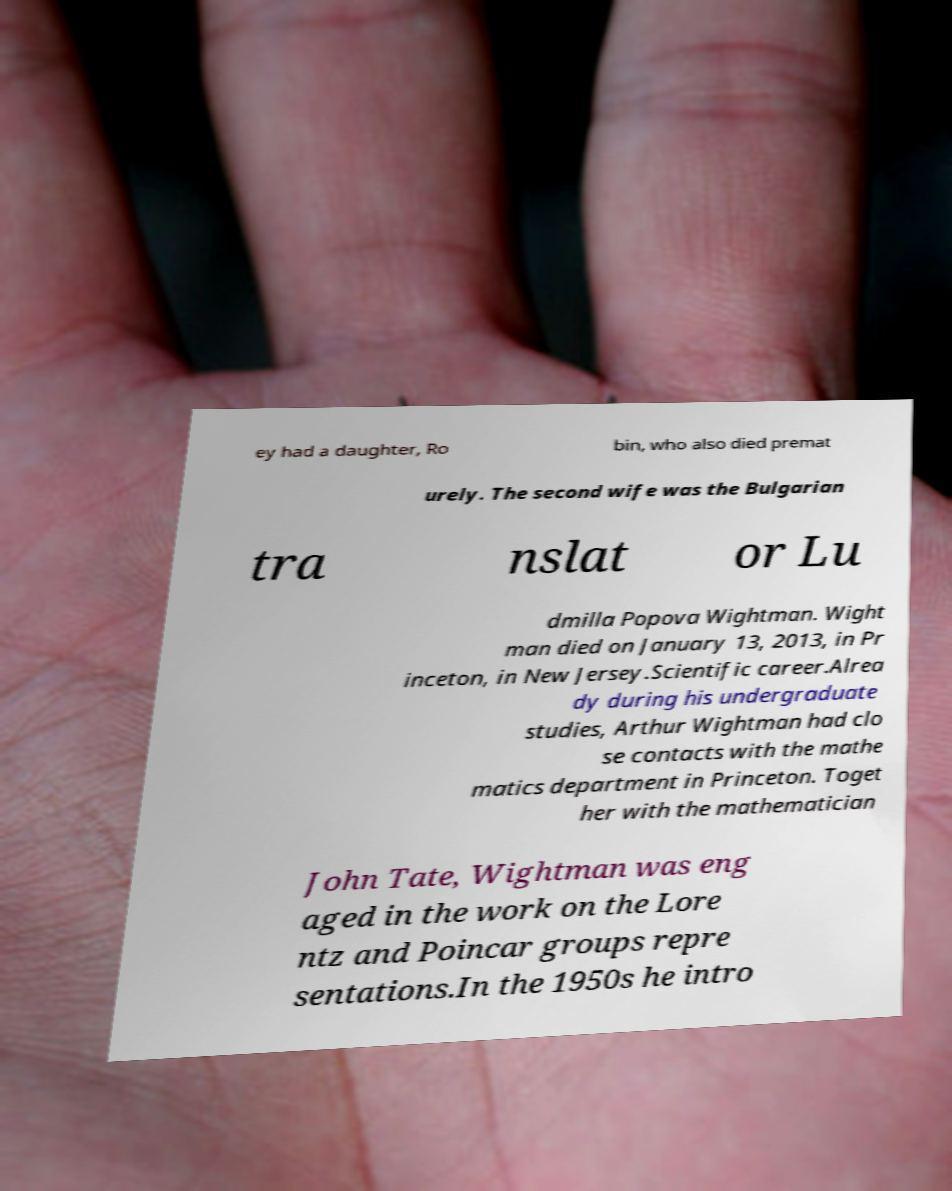Please identify and transcribe the text found in this image. ey had a daughter, Ro bin, who also died premat urely. The second wife was the Bulgarian tra nslat or Lu dmilla Popova Wightman. Wight man died on January 13, 2013, in Pr inceton, in New Jersey.Scientific career.Alrea dy during his undergraduate studies, Arthur Wightman had clo se contacts with the mathe matics department in Princeton. Toget her with the mathematician John Tate, Wightman was eng aged in the work on the Lore ntz and Poincar groups repre sentations.In the 1950s he intro 